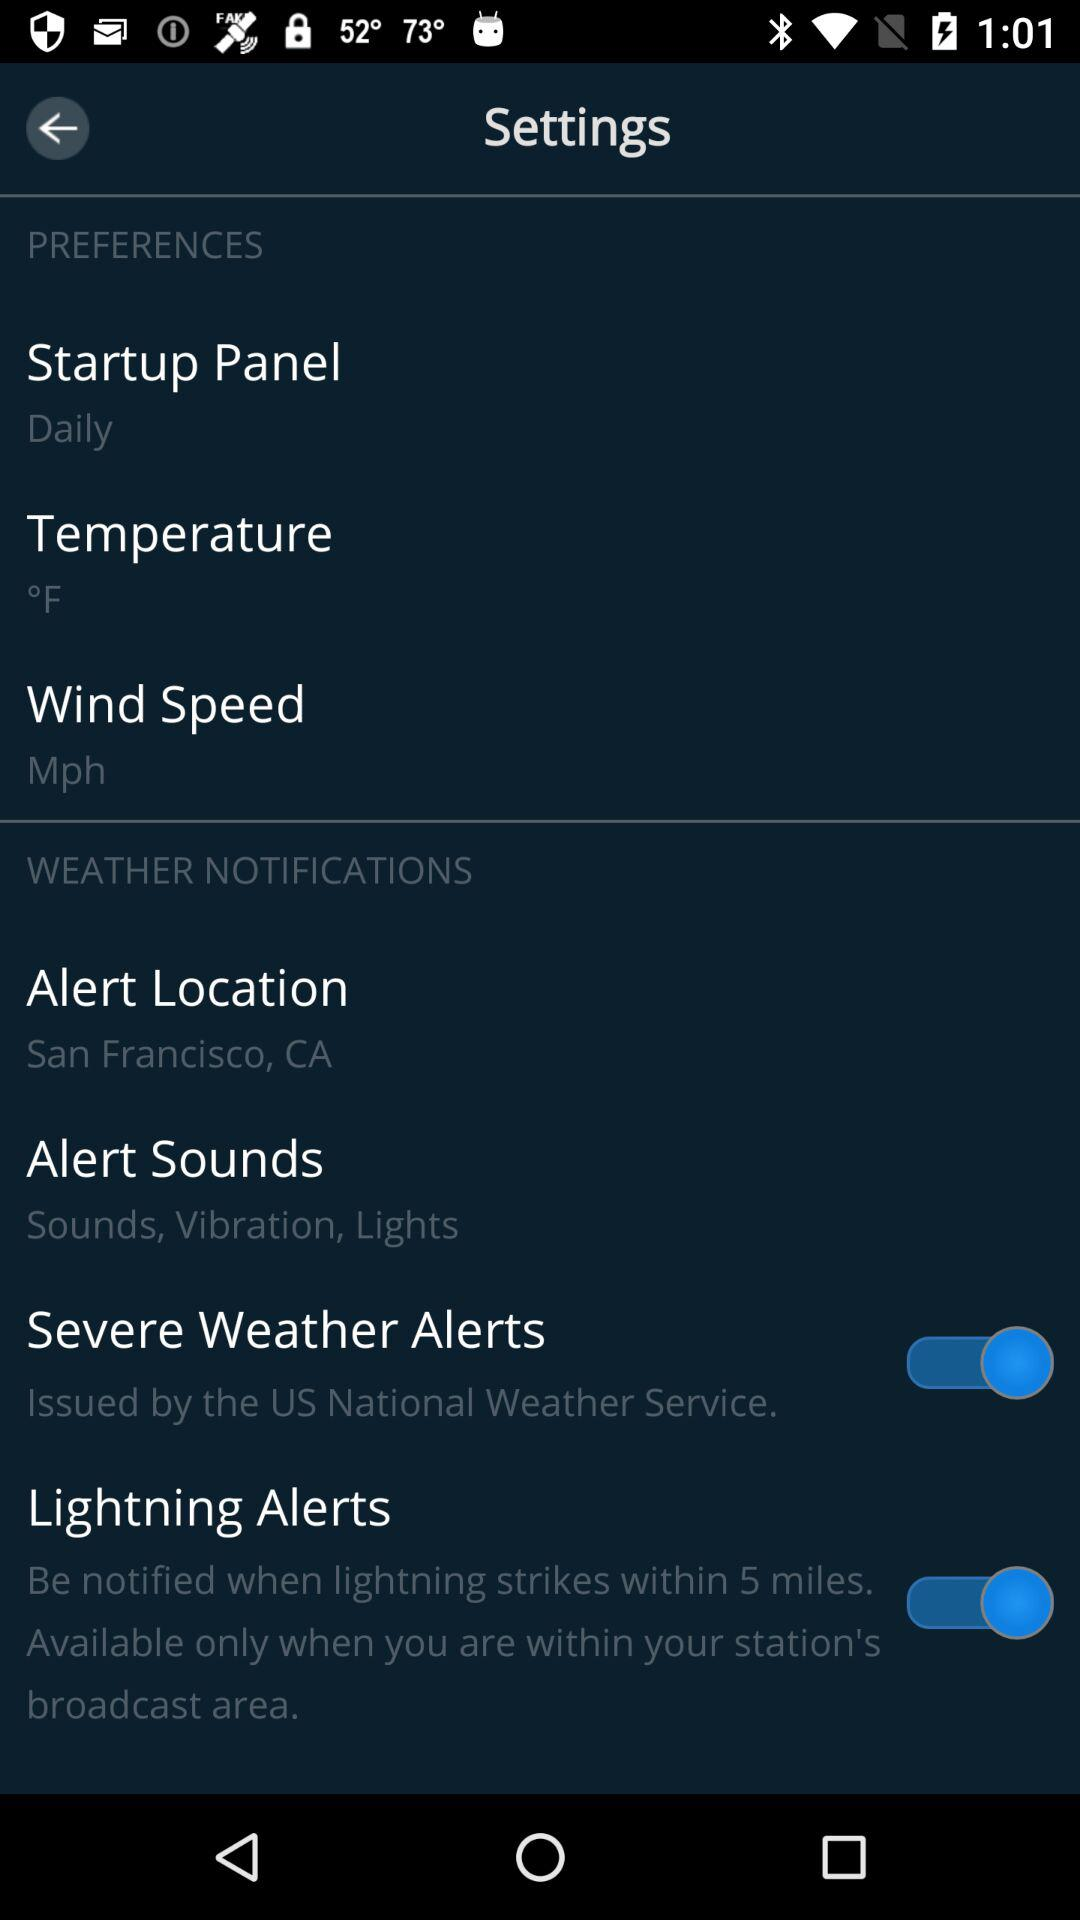What is the status of "Severe Weather Alerts"? The status is "on". 